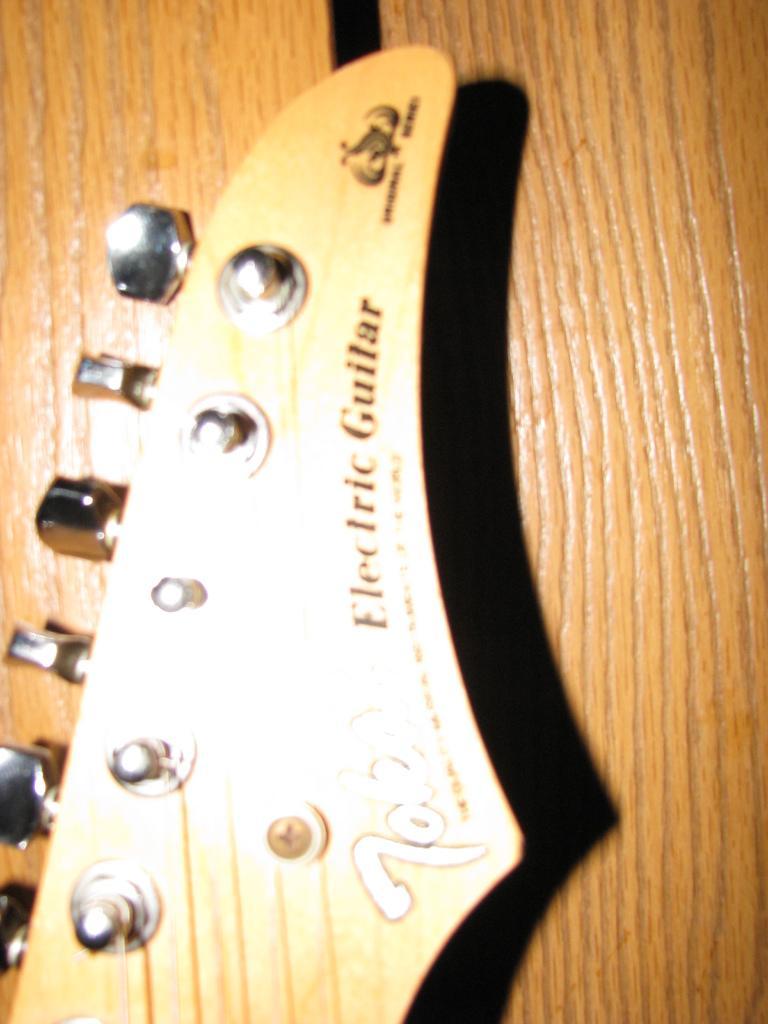Describe this image in one or two sentences. In this image we can see a guitar. 